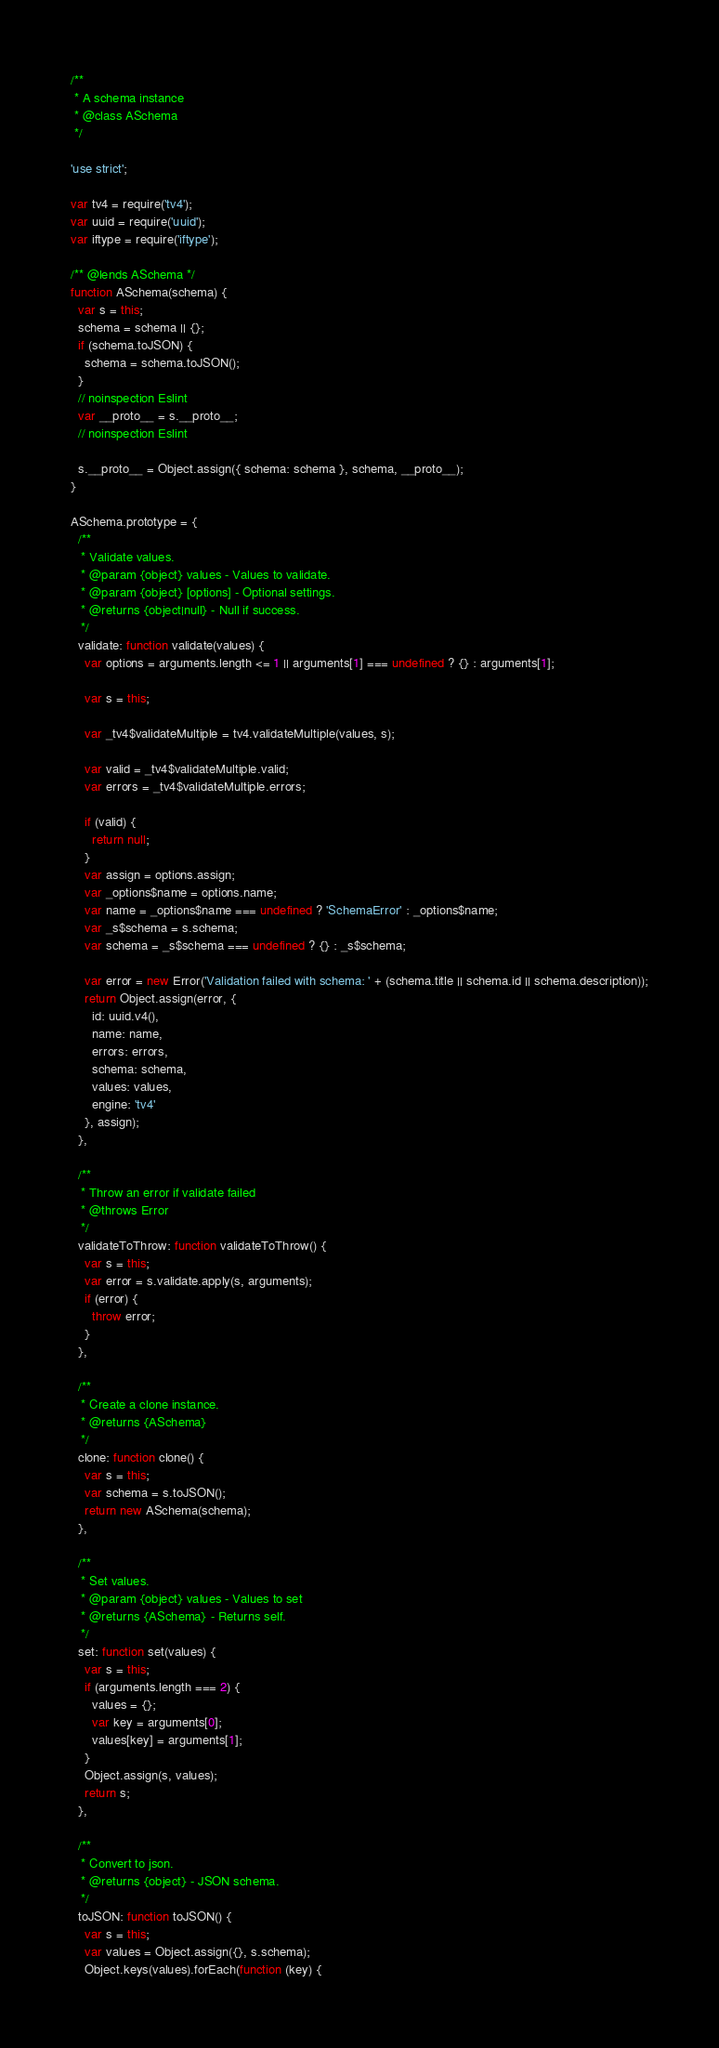<code> <loc_0><loc_0><loc_500><loc_500><_JavaScript_>/**
 * A schema instance
 * @class ASchema
 */

'use strict';

var tv4 = require('tv4');
var uuid = require('uuid');
var iftype = require('iftype');

/** @lends ASchema */
function ASchema(schema) {
  var s = this;
  schema = schema || {};
  if (schema.toJSON) {
    schema = schema.toJSON();
  }
  // noinspection Eslint
  var __proto__ = s.__proto__;
  // noinspection Eslint

  s.__proto__ = Object.assign({ schema: schema }, schema, __proto__);
}

ASchema.prototype = {
  /**
   * Validate values.
   * @param {object} values - Values to validate.
   * @param {object} [options] - Optional settings.
   * @returns {object|null} - Null if success.
   */
  validate: function validate(values) {
    var options = arguments.length <= 1 || arguments[1] === undefined ? {} : arguments[1];

    var s = this;

    var _tv4$validateMultiple = tv4.validateMultiple(values, s);

    var valid = _tv4$validateMultiple.valid;
    var errors = _tv4$validateMultiple.errors;

    if (valid) {
      return null;
    }
    var assign = options.assign;
    var _options$name = options.name;
    var name = _options$name === undefined ? 'SchemaError' : _options$name;
    var _s$schema = s.schema;
    var schema = _s$schema === undefined ? {} : _s$schema;

    var error = new Error('Validation failed with schema: ' + (schema.title || schema.id || schema.description));
    return Object.assign(error, {
      id: uuid.v4(),
      name: name,
      errors: errors,
      schema: schema,
      values: values,
      engine: 'tv4'
    }, assign);
  },

  /**
   * Throw an error if validate failed
   * @throws Error
   */
  validateToThrow: function validateToThrow() {
    var s = this;
    var error = s.validate.apply(s, arguments);
    if (error) {
      throw error;
    }
  },

  /**
   * Create a clone instance.
   * @returns {ASchema}
   */
  clone: function clone() {
    var s = this;
    var schema = s.toJSON();
    return new ASchema(schema);
  },

  /**
   * Set values.
   * @param {object} values - Values to set
   * @returns {ASchema} - Returns self.
   */
  set: function set(values) {
    var s = this;
    if (arguments.length === 2) {
      values = {};
      var key = arguments[0];
      values[key] = arguments[1];
    }
    Object.assign(s, values);
    return s;
  },

  /**
   * Convert to json.
   * @returns {object} - JSON schema.
   */
  toJSON: function toJSON() {
    var s = this;
    var values = Object.assign({}, s.schema);
    Object.keys(values).forEach(function (key) {</code> 